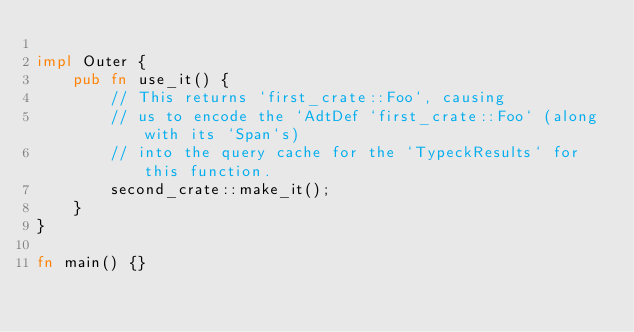Convert code to text. <code><loc_0><loc_0><loc_500><loc_500><_Rust_>
impl Outer {
    pub fn use_it() {
        // This returns `first_crate::Foo`, causing
        // us to encode the `AdtDef `first_crate::Foo` (along with its `Span`s)
        // into the query cache for the `TypeckResults` for this function.
        second_crate::make_it();
    }
}

fn main() {}
</code> 